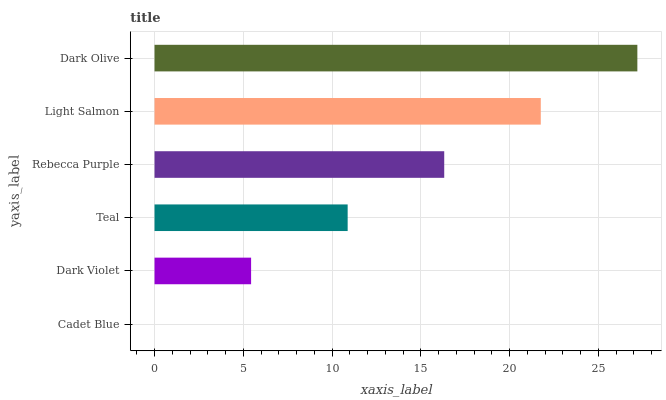Is Cadet Blue the minimum?
Answer yes or no. Yes. Is Dark Olive the maximum?
Answer yes or no. Yes. Is Dark Violet the minimum?
Answer yes or no. No. Is Dark Violet the maximum?
Answer yes or no. No. Is Dark Violet greater than Cadet Blue?
Answer yes or no. Yes. Is Cadet Blue less than Dark Violet?
Answer yes or no. Yes. Is Cadet Blue greater than Dark Violet?
Answer yes or no. No. Is Dark Violet less than Cadet Blue?
Answer yes or no. No. Is Rebecca Purple the high median?
Answer yes or no. Yes. Is Teal the low median?
Answer yes or no. Yes. Is Teal the high median?
Answer yes or no. No. Is Dark Violet the low median?
Answer yes or no. No. 